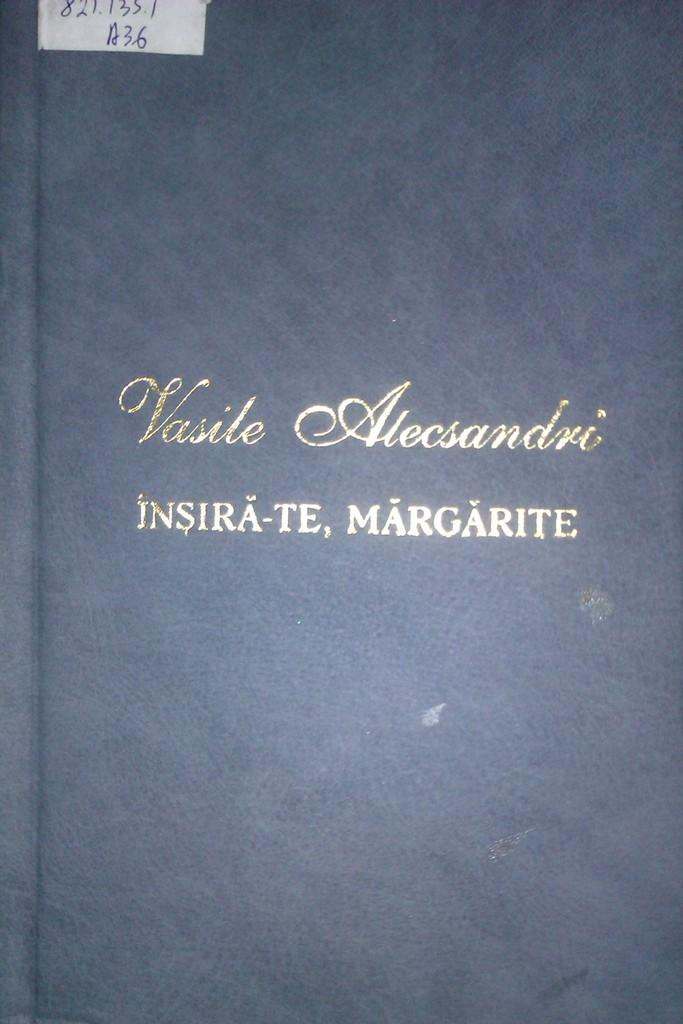<image>
Provide a brief description of the given image. A blue leather bound book has Vasile on the front cover. 